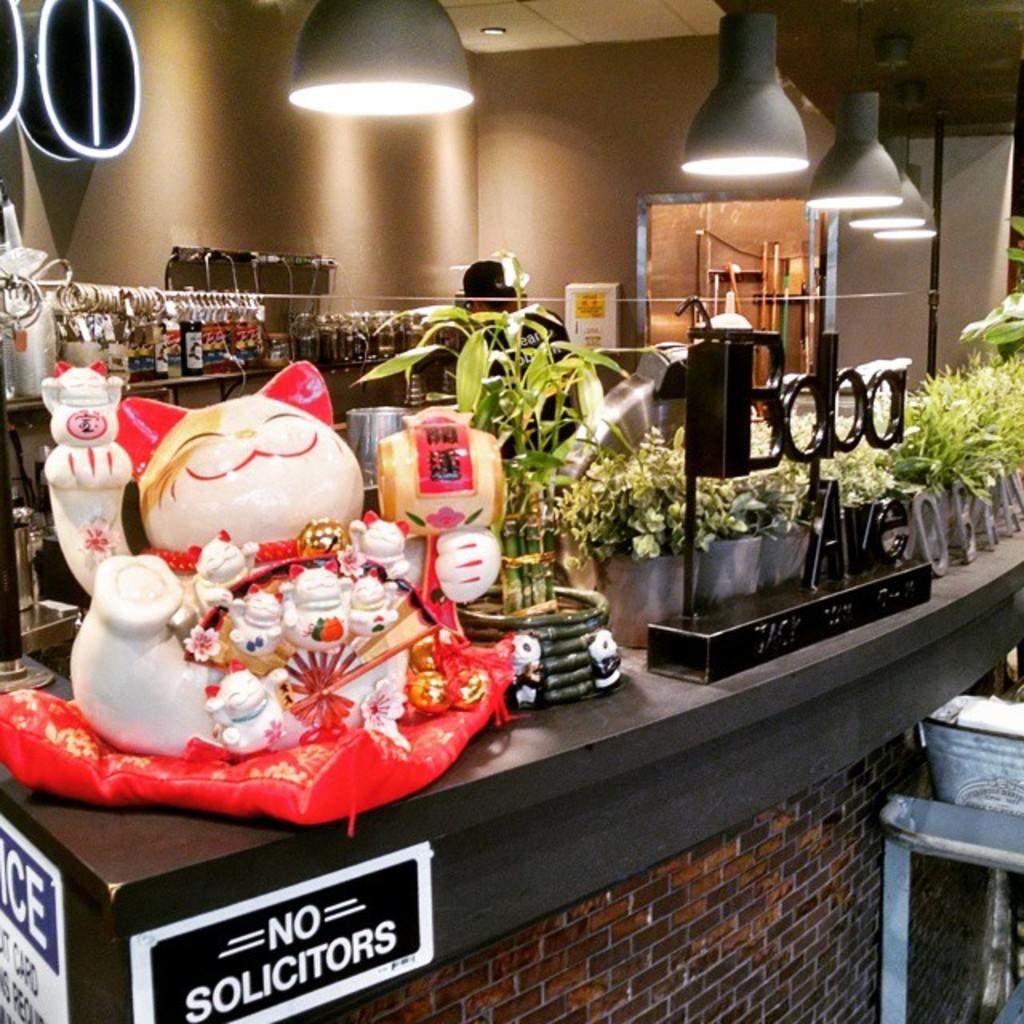<image>
Offer a succinct explanation of the picture presented. a dining area counter that has a sign that says no solicitors 